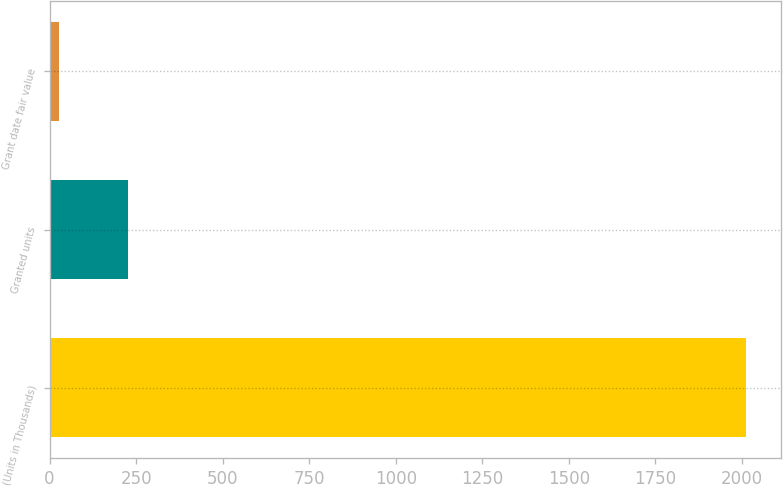<chart> <loc_0><loc_0><loc_500><loc_500><bar_chart><fcel>(Units in Thousands)<fcel>Granted units<fcel>Grant date fair value<nl><fcel>2012<fcel>225.87<fcel>27.41<nl></chart> 